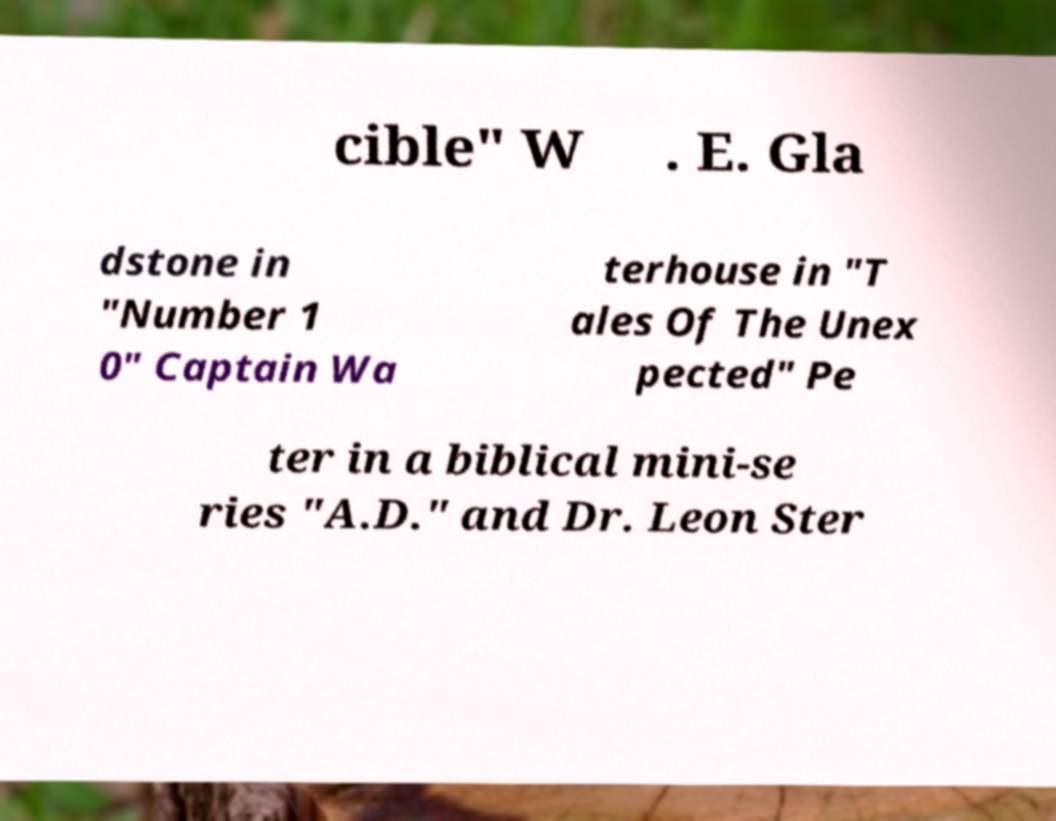Can you read and provide the text displayed in the image?This photo seems to have some interesting text. Can you extract and type it out for me? cible" W . E. Gla dstone in "Number 1 0" Captain Wa terhouse in "T ales Of The Unex pected" Pe ter in a biblical mini-se ries "A.D." and Dr. Leon Ster 